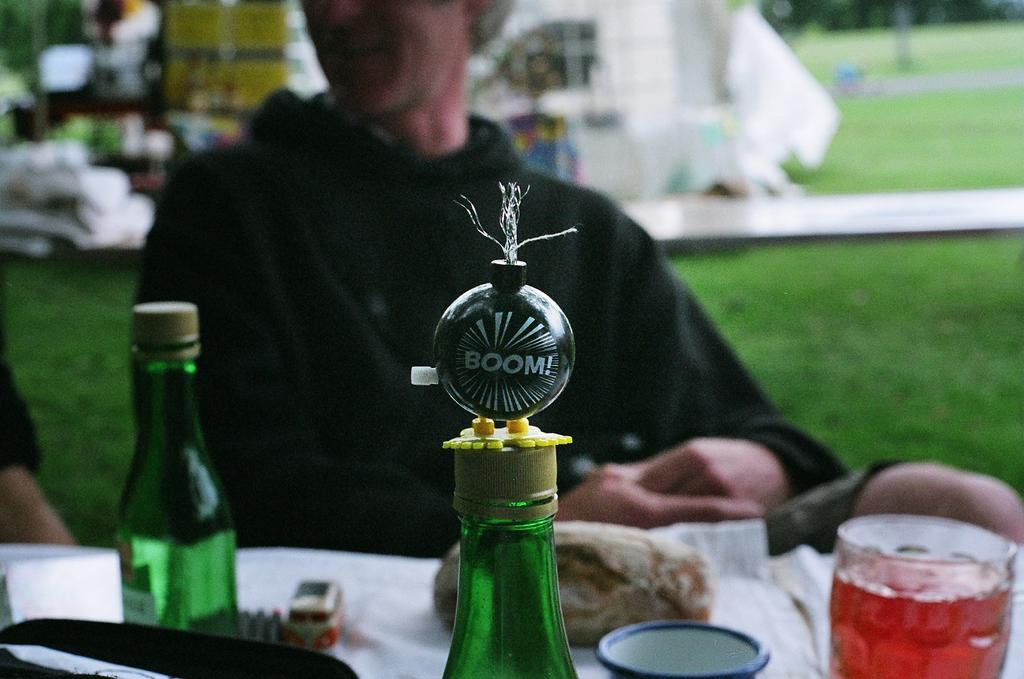Who is present in the image? There is a man in the image. What is the man doing in the image? The man is sitting on a chair. What can be seen on the table in the image? There are glass bottles of green color and a glass of wine on the table. What is the ground surface like behind the man? There is grass visible on the ground behind the man. Where is the brick wall located in the image? There is no brick wall present in the image. What type of map is the man holding in the image? The man is not holding a map in the image. 